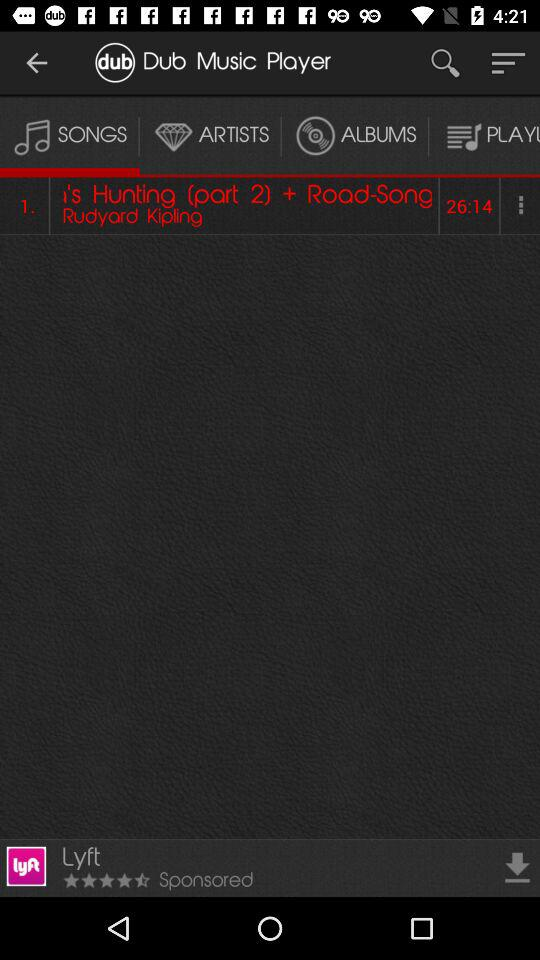What is the application name? The application name is "Dub Music Player". 